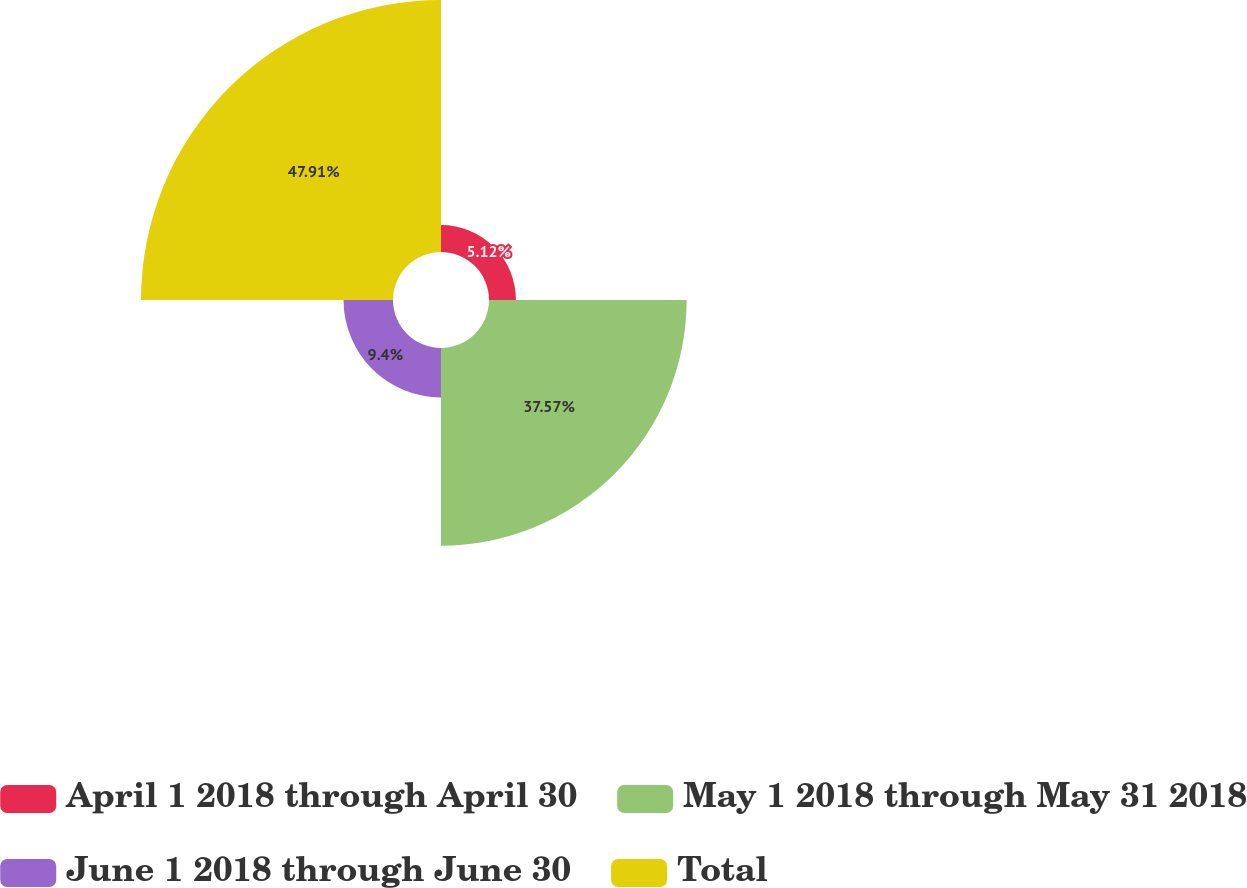Convert chart to OTSL. <chart><loc_0><loc_0><loc_500><loc_500><pie_chart><fcel>April 1 2018 through April 30<fcel>May 1 2018 through May 31 2018<fcel>June 1 2018 through June 30<fcel>Total<nl><fcel>5.12%<fcel>37.57%<fcel>9.4%<fcel>47.9%<nl></chart> 